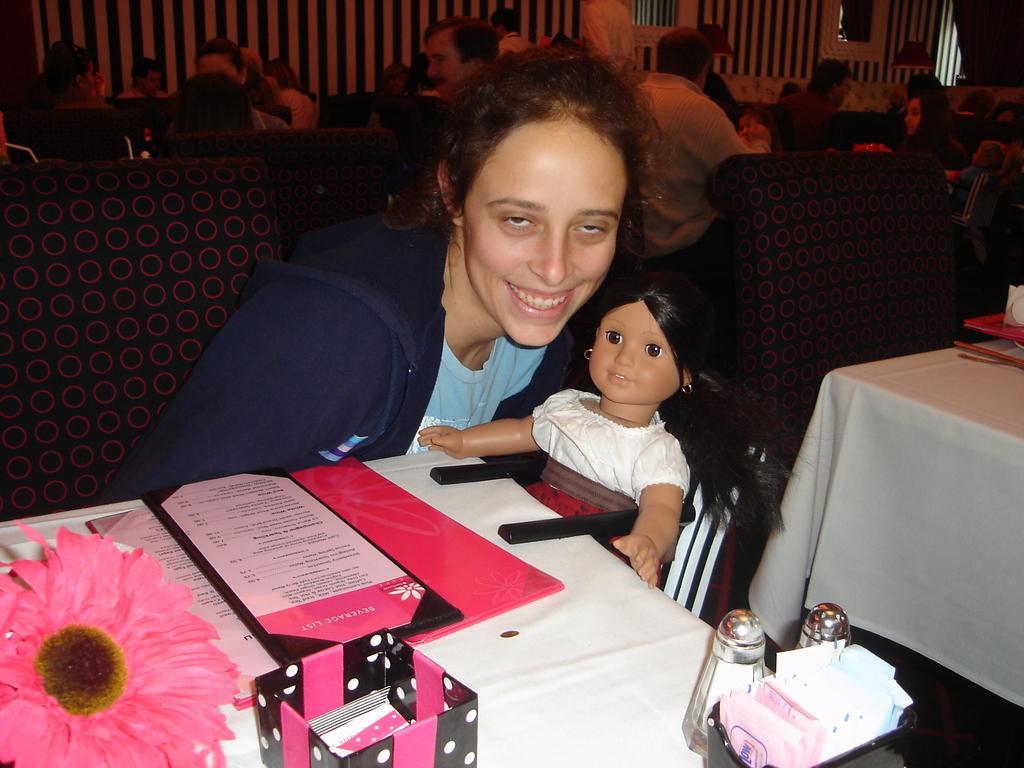How would you summarize this image in a sentence or two? In this image in the center, there is a woman sitting and smiling and holding a doll in her hand. In the front there is a table, on the table there are glasses, there is a flower and there are papers. In the background there are persons sitting. On the right side there is an empty chair and there is a table which is covered with a white colour cloth. On the table there are objects which are red and white in colour. 